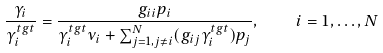Convert formula to latex. <formula><loc_0><loc_0><loc_500><loc_500>\frac { \gamma _ { i } } { \gamma _ { i } ^ { t g t } } = \frac { g _ { i i } p _ { i } } { \gamma _ { i } ^ { t g t } \nu _ { i } + \sum _ { j = 1 , j \neq i } ^ { N } ( g _ { i j } \gamma _ { i } ^ { t g t } ) p _ { j } } , \quad i = 1 , \dots , N</formula> 